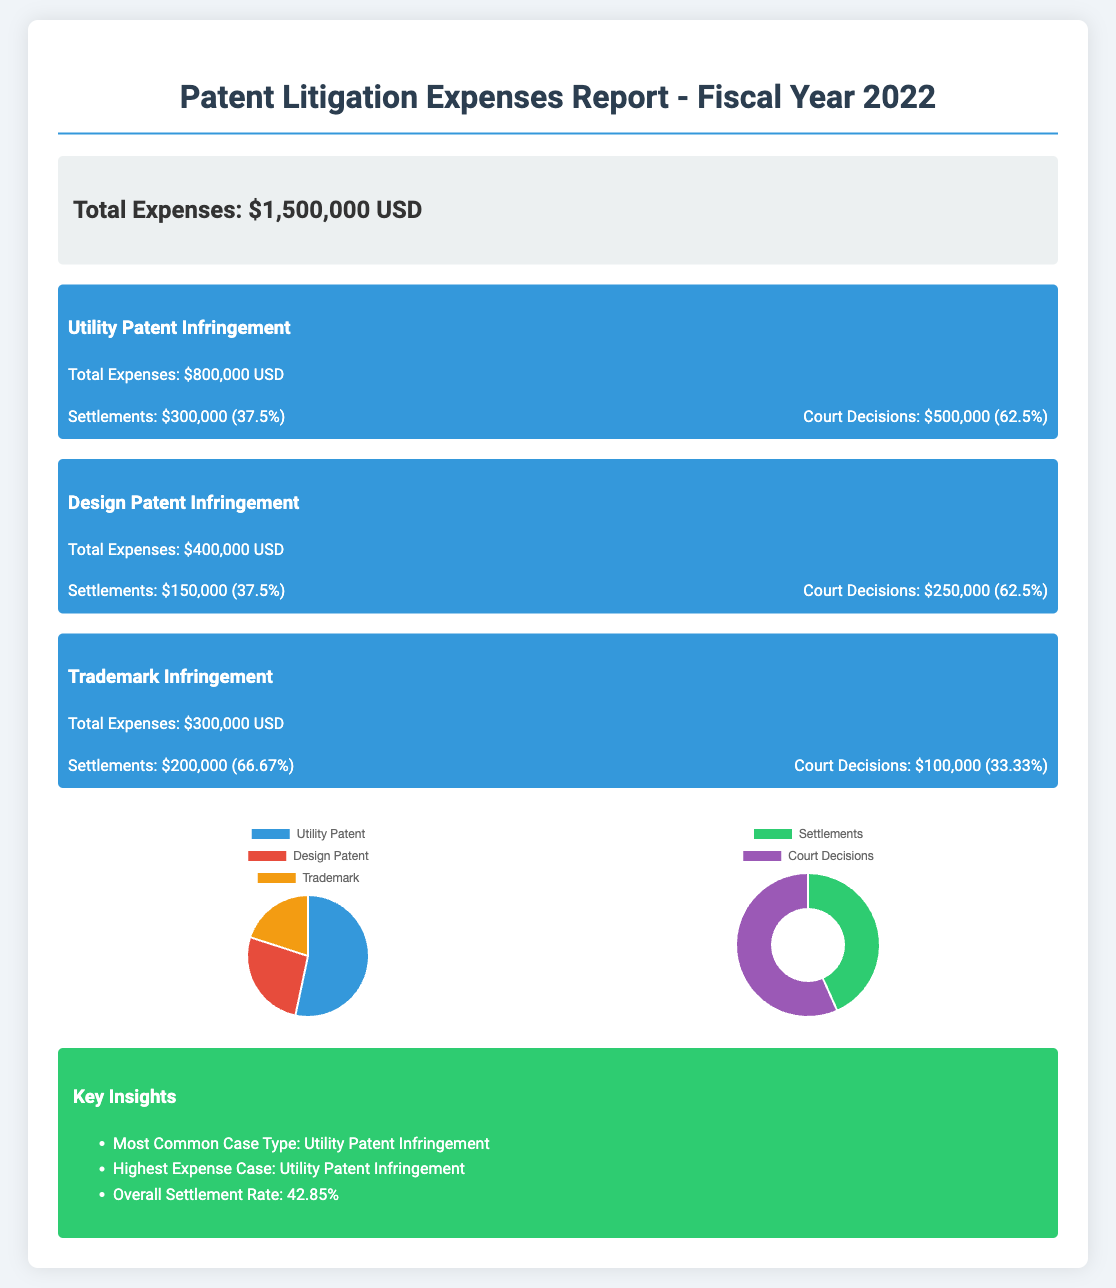What was the total expense for the fiscal year 2022? The total expense for the fiscal year 2022 is stated as $1,500,000 USD in the document.
Answer: $1,500,000 USD What are the total expenses for Utility Patent Infringement? The total expenses for Utility Patent Infringement are specified in the document as $800,000 USD.
Answer: $800,000 USD What percentage of the expenses for Design Patent Infringement were for court decisions? The document indicates that 62.5% of the expenses for Design Patent Infringement were for court decisions.
Answer: 62.5% Which case type had the highest expense? The document lists Utility Patent Infringement as the case type with the highest expense.
Answer: Utility Patent Infringement How much did Trademark Infringement settle for? The document shows that Trademark Infringement settled for $200,000.
Answer: $200,000 What is the overall settlement rate mentioned in the insights? The insights section mentions the overall settlement rate as 42.85%.
Answer: 42.85% How much was spent on settlements for all case types combined? The document provides the settlements for each case type, totaling $650,000.
Answer: $650,000 What does the chart show for expenses by case type? The chart visually represents the distribution of expenses by case type: Utility Patent, Design Patent, and Trademark.
Answer: Pie chart of expenses by case type How many court decisions are there in total across all case types? The total amount for court decisions across all cases sums to $850,000.
Answer: $850,000 